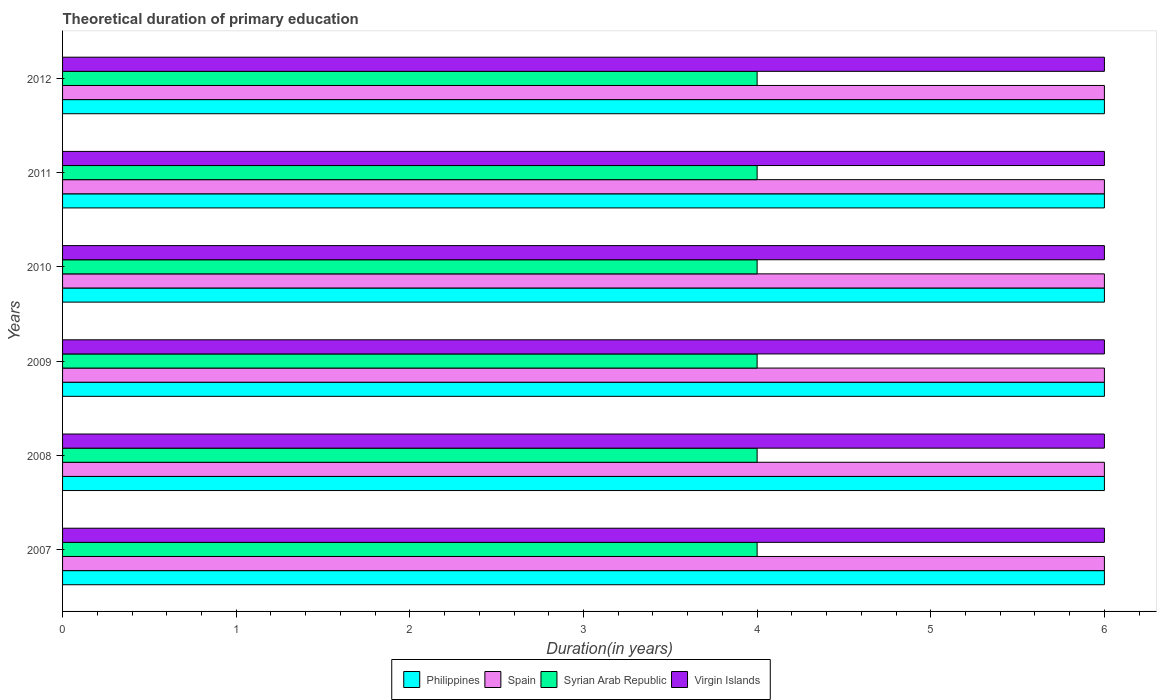How many different coloured bars are there?
Ensure brevity in your answer.  4. How many groups of bars are there?
Provide a short and direct response. 6. Are the number of bars on each tick of the Y-axis equal?
Offer a very short reply. Yes. What is the label of the 2nd group of bars from the top?
Offer a terse response. 2011. What is the total theoretical duration of primary education in Virgin Islands in 2010?
Give a very brief answer. 6. Across all years, what is the minimum total theoretical duration of primary education in Philippines?
Make the answer very short. 6. In which year was the total theoretical duration of primary education in Virgin Islands maximum?
Your answer should be compact. 2007. In which year was the total theoretical duration of primary education in Virgin Islands minimum?
Your answer should be very brief. 2007. What is the total total theoretical duration of primary education in Philippines in the graph?
Give a very brief answer. 36. What is the difference between the total theoretical duration of primary education in Syrian Arab Republic in 2009 and that in 2010?
Make the answer very short. 0. What is the difference between the total theoretical duration of primary education in Spain in 2007 and the total theoretical duration of primary education in Virgin Islands in 2012?
Your response must be concise. 0. In how many years, is the total theoretical duration of primary education in Spain greater than 4 years?
Your answer should be compact. 6. What is the ratio of the total theoretical duration of primary education in Spain in 2009 to that in 2011?
Provide a succinct answer. 1. Is the total theoretical duration of primary education in Philippines in 2011 less than that in 2012?
Keep it short and to the point. No. Is the difference between the total theoretical duration of primary education in Philippines in 2010 and 2011 greater than the difference between the total theoretical duration of primary education in Spain in 2010 and 2011?
Provide a short and direct response. No. What is the difference between the highest and the lowest total theoretical duration of primary education in Spain?
Make the answer very short. 0. In how many years, is the total theoretical duration of primary education in Virgin Islands greater than the average total theoretical duration of primary education in Virgin Islands taken over all years?
Make the answer very short. 0. Is the sum of the total theoretical duration of primary education in Syrian Arab Republic in 2007 and 2010 greater than the maximum total theoretical duration of primary education in Virgin Islands across all years?
Give a very brief answer. Yes. What does the 3rd bar from the top in 2012 represents?
Make the answer very short. Spain. What does the 4th bar from the bottom in 2012 represents?
Your response must be concise. Virgin Islands. Are all the bars in the graph horizontal?
Give a very brief answer. Yes. Are the values on the major ticks of X-axis written in scientific E-notation?
Keep it short and to the point. No. Does the graph contain grids?
Ensure brevity in your answer.  No. Where does the legend appear in the graph?
Ensure brevity in your answer.  Bottom center. How are the legend labels stacked?
Your response must be concise. Horizontal. What is the title of the graph?
Offer a very short reply. Theoretical duration of primary education. Does "Vanuatu" appear as one of the legend labels in the graph?
Make the answer very short. No. What is the label or title of the X-axis?
Your response must be concise. Duration(in years). What is the Duration(in years) of Philippines in 2007?
Provide a short and direct response. 6. What is the Duration(in years) in Spain in 2007?
Provide a short and direct response. 6. What is the Duration(in years) in Virgin Islands in 2007?
Keep it short and to the point. 6. What is the Duration(in years) of Spain in 2008?
Make the answer very short. 6. What is the Duration(in years) in Spain in 2009?
Your answer should be very brief. 6. What is the Duration(in years) of Syrian Arab Republic in 2009?
Your answer should be very brief. 4. What is the Duration(in years) in Virgin Islands in 2009?
Offer a terse response. 6. What is the Duration(in years) of Spain in 2010?
Offer a very short reply. 6. What is the Duration(in years) in Syrian Arab Republic in 2010?
Your response must be concise. 4. What is the Duration(in years) of Virgin Islands in 2010?
Provide a succinct answer. 6. Across all years, what is the maximum Duration(in years) in Philippines?
Your answer should be compact. 6. Across all years, what is the maximum Duration(in years) of Spain?
Your answer should be compact. 6. Across all years, what is the maximum Duration(in years) in Syrian Arab Republic?
Make the answer very short. 4. Across all years, what is the maximum Duration(in years) of Virgin Islands?
Give a very brief answer. 6. What is the total Duration(in years) in Philippines in the graph?
Your answer should be compact. 36. What is the total Duration(in years) of Spain in the graph?
Your answer should be compact. 36. What is the total Duration(in years) of Syrian Arab Republic in the graph?
Keep it short and to the point. 24. What is the total Duration(in years) in Virgin Islands in the graph?
Provide a short and direct response. 36. What is the difference between the Duration(in years) in Philippines in 2007 and that in 2008?
Give a very brief answer. 0. What is the difference between the Duration(in years) of Spain in 2007 and that in 2009?
Your answer should be compact. 0. What is the difference between the Duration(in years) in Virgin Islands in 2007 and that in 2009?
Your response must be concise. 0. What is the difference between the Duration(in years) in Philippines in 2007 and that in 2010?
Keep it short and to the point. 0. What is the difference between the Duration(in years) in Syrian Arab Republic in 2007 and that in 2011?
Offer a very short reply. 0. What is the difference between the Duration(in years) in Virgin Islands in 2007 and that in 2011?
Your answer should be compact. 0. What is the difference between the Duration(in years) of Philippines in 2007 and that in 2012?
Offer a terse response. 0. What is the difference between the Duration(in years) of Spain in 2007 and that in 2012?
Your answer should be compact. 0. What is the difference between the Duration(in years) of Philippines in 2008 and that in 2009?
Ensure brevity in your answer.  0. What is the difference between the Duration(in years) in Syrian Arab Republic in 2008 and that in 2009?
Provide a short and direct response. 0. What is the difference between the Duration(in years) in Virgin Islands in 2008 and that in 2009?
Ensure brevity in your answer.  0. What is the difference between the Duration(in years) in Spain in 2008 and that in 2010?
Keep it short and to the point. 0. What is the difference between the Duration(in years) in Syrian Arab Republic in 2008 and that in 2010?
Your answer should be very brief. 0. What is the difference between the Duration(in years) of Spain in 2008 and that in 2011?
Offer a very short reply. 0. What is the difference between the Duration(in years) of Virgin Islands in 2008 and that in 2011?
Offer a very short reply. 0. What is the difference between the Duration(in years) of Spain in 2008 and that in 2012?
Provide a short and direct response. 0. What is the difference between the Duration(in years) of Syrian Arab Republic in 2008 and that in 2012?
Give a very brief answer. 0. What is the difference between the Duration(in years) of Virgin Islands in 2008 and that in 2012?
Provide a short and direct response. 0. What is the difference between the Duration(in years) of Philippines in 2009 and that in 2010?
Your answer should be very brief. 0. What is the difference between the Duration(in years) of Syrian Arab Republic in 2009 and that in 2010?
Your answer should be compact. 0. What is the difference between the Duration(in years) in Virgin Islands in 2009 and that in 2010?
Provide a succinct answer. 0. What is the difference between the Duration(in years) in Syrian Arab Republic in 2009 and that in 2011?
Your answer should be compact. 0. What is the difference between the Duration(in years) of Syrian Arab Republic in 2009 and that in 2012?
Offer a terse response. 0. What is the difference between the Duration(in years) in Virgin Islands in 2009 and that in 2012?
Provide a short and direct response. 0. What is the difference between the Duration(in years) of Spain in 2010 and that in 2011?
Offer a terse response. 0. What is the difference between the Duration(in years) in Virgin Islands in 2010 and that in 2011?
Ensure brevity in your answer.  0. What is the difference between the Duration(in years) in Syrian Arab Republic in 2010 and that in 2012?
Ensure brevity in your answer.  0. What is the difference between the Duration(in years) of Virgin Islands in 2010 and that in 2012?
Your response must be concise. 0. What is the difference between the Duration(in years) of Philippines in 2011 and that in 2012?
Your response must be concise. 0. What is the difference between the Duration(in years) in Syrian Arab Republic in 2011 and that in 2012?
Offer a terse response. 0. What is the difference between the Duration(in years) in Virgin Islands in 2011 and that in 2012?
Make the answer very short. 0. What is the difference between the Duration(in years) of Philippines in 2007 and the Duration(in years) of Virgin Islands in 2008?
Provide a short and direct response. 0. What is the difference between the Duration(in years) in Syrian Arab Republic in 2007 and the Duration(in years) in Virgin Islands in 2008?
Provide a short and direct response. -2. What is the difference between the Duration(in years) of Philippines in 2007 and the Duration(in years) of Spain in 2009?
Offer a very short reply. 0. What is the difference between the Duration(in years) in Philippines in 2007 and the Duration(in years) in Syrian Arab Republic in 2009?
Your response must be concise. 2. What is the difference between the Duration(in years) in Philippines in 2007 and the Duration(in years) in Virgin Islands in 2009?
Keep it short and to the point. 0. What is the difference between the Duration(in years) of Spain in 2007 and the Duration(in years) of Syrian Arab Republic in 2009?
Ensure brevity in your answer.  2. What is the difference between the Duration(in years) in Spain in 2007 and the Duration(in years) in Virgin Islands in 2009?
Provide a short and direct response. 0. What is the difference between the Duration(in years) in Syrian Arab Republic in 2007 and the Duration(in years) in Virgin Islands in 2009?
Keep it short and to the point. -2. What is the difference between the Duration(in years) in Philippines in 2007 and the Duration(in years) in Spain in 2010?
Make the answer very short. 0. What is the difference between the Duration(in years) in Philippines in 2007 and the Duration(in years) in Syrian Arab Republic in 2010?
Ensure brevity in your answer.  2. What is the difference between the Duration(in years) of Spain in 2007 and the Duration(in years) of Syrian Arab Republic in 2010?
Give a very brief answer. 2. What is the difference between the Duration(in years) in Philippines in 2007 and the Duration(in years) in Spain in 2011?
Your answer should be very brief. 0. What is the difference between the Duration(in years) in Spain in 2007 and the Duration(in years) in Syrian Arab Republic in 2011?
Your answer should be compact. 2. What is the difference between the Duration(in years) in Syrian Arab Republic in 2007 and the Duration(in years) in Virgin Islands in 2011?
Your response must be concise. -2. What is the difference between the Duration(in years) in Philippines in 2007 and the Duration(in years) in Spain in 2012?
Make the answer very short. 0. What is the difference between the Duration(in years) of Philippines in 2007 and the Duration(in years) of Syrian Arab Republic in 2012?
Offer a terse response. 2. What is the difference between the Duration(in years) in Spain in 2007 and the Duration(in years) in Syrian Arab Republic in 2012?
Ensure brevity in your answer.  2. What is the difference between the Duration(in years) in Spain in 2007 and the Duration(in years) in Virgin Islands in 2012?
Provide a succinct answer. 0. What is the difference between the Duration(in years) of Philippines in 2008 and the Duration(in years) of Syrian Arab Republic in 2009?
Ensure brevity in your answer.  2. What is the difference between the Duration(in years) in Philippines in 2008 and the Duration(in years) in Virgin Islands in 2009?
Your answer should be very brief. 0. What is the difference between the Duration(in years) of Spain in 2008 and the Duration(in years) of Virgin Islands in 2009?
Keep it short and to the point. 0. What is the difference between the Duration(in years) in Syrian Arab Republic in 2008 and the Duration(in years) in Virgin Islands in 2009?
Your answer should be compact. -2. What is the difference between the Duration(in years) of Philippines in 2008 and the Duration(in years) of Syrian Arab Republic in 2010?
Offer a very short reply. 2. What is the difference between the Duration(in years) in Spain in 2008 and the Duration(in years) in Syrian Arab Republic in 2010?
Keep it short and to the point. 2. What is the difference between the Duration(in years) of Syrian Arab Republic in 2008 and the Duration(in years) of Virgin Islands in 2010?
Provide a short and direct response. -2. What is the difference between the Duration(in years) in Philippines in 2008 and the Duration(in years) in Spain in 2011?
Give a very brief answer. 0. What is the difference between the Duration(in years) of Philippines in 2008 and the Duration(in years) of Syrian Arab Republic in 2011?
Your answer should be very brief. 2. What is the difference between the Duration(in years) in Spain in 2008 and the Duration(in years) in Virgin Islands in 2011?
Ensure brevity in your answer.  0. What is the difference between the Duration(in years) in Philippines in 2008 and the Duration(in years) in Syrian Arab Republic in 2012?
Make the answer very short. 2. What is the difference between the Duration(in years) in Spain in 2008 and the Duration(in years) in Syrian Arab Republic in 2012?
Your answer should be compact. 2. What is the difference between the Duration(in years) in Philippines in 2009 and the Duration(in years) in Spain in 2010?
Provide a short and direct response. 0. What is the difference between the Duration(in years) in Philippines in 2009 and the Duration(in years) in Syrian Arab Republic in 2010?
Give a very brief answer. 2. What is the difference between the Duration(in years) in Spain in 2009 and the Duration(in years) in Syrian Arab Republic in 2010?
Offer a terse response. 2. What is the difference between the Duration(in years) of Spain in 2009 and the Duration(in years) of Virgin Islands in 2010?
Provide a short and direct response. 0. What is the difference between the Duration(in years) in Syrian Arab Republic in 2009 and the Duration(in years) in Virgin Islands in 2010?
Offer a very short reply. -2. What is the difference between the Duration(in years) in Philippines in 2009 and the Duration(in years) in Spain in 2011?
Your response must be concise. 0. What is the difference between the Duration(in years) in Philippines in 2009 and the Duration(in years) in Virgin Islands in 2011?
Make the answer very short. 0. What is the difference between the Duration(in years) of Philippines in 2009 and the Duration(in years) of Virgin Islands in 2012?
Ensure brevity in your answer.  0. What is the difference between the Duration(in years) in Philippines in 2010 and the Duration(in years) in Syrian Arab Republic in 2011?
Make the answer very short. 2. What is the difference between the Duration(in years) of Spain in 2010 and the Duration(in years) of Syrian Arab Republic in 2011?
Your answer should be very brief. 2. What is the difference between the Duration(in years) in Spain in 2010 and the Duration(in years) in Virgin Islands in 2011?
Provide a succinct answer. 0. What is the difference between the Duration(in years) in Philippines in 2010 and the Duration(in years) in Spain in 2012?
Give a very brief answer. 0. What is the difference between the Duration(in years) of Philippines in 2010 and the Duration(in years) of Syrian Arab Republic in 2012?
Provide a succinct answer. 2. What is the difference between the Duration(in years) in Philippines in 2011 and the Duration(in years) in Spain in 2012?
Your answer should be compact. 0. What is the average Duration(in years) in Philippines per year?
Your answer should be compact. 6. In the year 2007, what is the difference between the Duration(in years) of Spain and Duration(in years) of Syrian Arab Republic?
Your response must be concise. 2. In the year 2008, what is the difference between the Duration(in years) in Spain and Duration(in years) in Virgin Islands?
Provide a succinct answer. 0. In the year 2008, what is the difference between the Duration(in years) in Syrian Arab Republic and Duration(in years) in Virgin Islands?
Offer a very short reply. -2. In the year 2009, what is the difference between the Duration(in years) of Philippines and Duration(in years) of Spain?
Provide a short and direct response. 0. In the year 2009, what is the difference between the Duration(in years) of Philippines and Duration(in years) of Syrian Arab Republic?
Provide a short and direct response. 2. In the year 2009, what is the difference between the Duration(in years) of Philippines and Duration(in years) of Virgin Islands?
Your answer should be very brief. 0. In the year 2009, what is the difference between the Duration(in years) of Spain and Duration(in years) of Syrian Arab Republic?
Provide a short and direct response. 2. In the year 2009, what is the difference between the Duration(in years) in Spain and Duration(in years) in Virgin Islands?
Your answer should be very brief. 0. In the year 2010, what is the difference between the Duration(in years) in Philippines and Duration(in years) in Virgin Islands?
Make the answer very short. 0. In the year 2010, what is the difference between the Duration(in years) of Spain and Duration(in years) of Syrian Arab Republic?
Provide a succinct answer. 2. In the year 2010, what is the difference between the Duration(in years) in Syrian Arab Republic and Duration(in years) in Virgin Islands?
Provide a succinct answer. -2. In the year 2011, what is the difference between the Duration(in years) of Philippines and Duration(in years) of Spain?
Offer a very short reply. 0. In the year 2011, what is the difference between the Duration(in years) of Philippines and Duration(in years) of Syrian Arab Republic?
Provide a short and direct response. 2. In the year 2011, what is the difference between the Duration(in years) in Philippines and Duration(in years) in Virgin Islands?
Your answer should be compact. 0. In the year 2011, what is the difference between the Duration(in years) in Syrian Arab Republic and Duration(in years) in Virgin Islands?
Provide a succinct answer. -2. In the year 2012, what is the difference between the Duration(in years) in Philippines and Duration(in years) in Syrian Arab Republic?
Your answer should be very brief. 2. In the year 2012, what is the difference between the Duration(in years) in Philippines and Duration(in years) in Virgin Islands?
Keep it short and to the point. 0. In the year 2012, what is the difference between the Duration(in years) in Spain and Duration(in years) in Syrian Arab Republic?
Give a very brief answer. 2. What is the ratio of the Duration(in years) in Philippines in 2007 to that in 2008?
Offer a terse response. 1. What is the ratio of the Duration(in years) in Syrian Arab Republic in 2007 to that in 2008?
Your response must be concise. 1. What is the ratio of the Duration(in years) in Virgin Islands in 2007 to that in 2008?
Give a very brief answer. 1. What is the ratio of the Duration(in years) of Philippines in 2007 to that in 2009?
Your response must be concise. 1. What is the ratio of the Duration(in years) in Syrian Arab Republic in 2007 to that in 2009?
Your answer should be compact. 1. What is the ratio of the Duration(in years) in Virgin Islands in 2007 to that in 2009?
Keep it short and to the point. 1. What is the ratio of the Duration(in years) of Philippines in 2007 to that in 2010?
Your response must be concise. 1. What is the ratio of the Duration(in years) in Syrian Arab Republic in 2007 to that in 2010?
Provide a short and direct response. 1. What is the ratio of the Duration(in years) of Virgin Islands in 2007 to that in 2010?
Your answer should be compact. 1. What is the ratio of the Duration(in years) of Philippines in 2007 to that in 2011?
Your answer should be very brief. 1. What is the ratio of the Duration(in years) in Spain in 2007 to that in 2011?
Your response must be concise. 1. What is the ratio of the Duration(in years) in Syrian Arab Republic in 2007 to that in 2011?
Give a very brief answer. 1. What is the ratio of the Duration(in years) of Philippines in 2007 to that in 2012?
Ensure brevity in your answer.  1. What is the ratio of the Duration(in years) in Spain in 2007 to that in 2012?
Offer a terse response. 1. What is the ratio of the Duration(in years) of Virgin Islands in 2007 to that in 2012?
Your answer should be very brief. 1. What is the ratio of the Duration(in years) of Spain in 2008 to that in 2009?
Your answer should be very brief. 1. What is the ratio of the Duration(in years) of Philippines in 2008 to that in 2010?
Keep it short and to the point. 1. What is the ratio of the Duration(in years) of Spain in 2008 to that in 2010?
Offer a terse response. 1. What is the ratio of the Duration(in years) of Virgin Islands in 2008 to that in 2010?
Your answer should be very brief. 1. What is the ratio of the Duration(in years) in Spain in 2008 to that in 2011?
Provide a succinct answer. 1. What is the ratio of the Duration(in years) in Syrian Arab Republic in 2008 to that in 2011?
Offer a very short reply. 1. What is the ratio of the Duration(in years) of Virgin Islands in 2008 to that in 2011?
Offer a terse response. 1. What is the ratio of the Duration(in years) of Philippines in 2009 to that in 2010?
Your answer should be very brief. 1. What is the ratio of the Duration(in years) in Spain in 2009 to that in 2010?
Provide a short and direct response. 1. What is the ratio of the Duration(in years) of Syrian Arab Republic in 2009 to that in 2010?
Provide a short and direct response. 1. What is the ratio of the Duration(in years) of Virgin Islands in 2009 to that in 2010?
Your answer should be very brief. 1. What is the ratio of the Duration(in years) of Syrian Arab Republic in 2009 to that in 2011?
Offer a terse response. 1. What is the ratio of the Duration(in years) in Philippines in 2009 to that in 2012?
Provide a short and direct response. 1. What is the ratio of the Duration(in years) of Spain in 2009 to that in 2012?
Ensure brevity in your answer.  1. What is the ratio of the Duration(in years) in Philippines in 2010 to that in 2011?
Your response must be concise. 1. What is the ratio of the Duration(in years) of Spain in 2010 to that in 2011?
Provide a succinct answer. 1. What is the ratio of the Duration(in years) of Syrian Arab Republic in 2010 to that in 2011?
Your answer should be very brief. 1. What is the ratio of the Duration(in years) of Virgin Islands in 2010 to that in 2011?
Your response must be concise. 1. What is the ratio of the Duration(in years) of Spain in 2010 to that in 2012?
Your answer should be compact. 1. What is the difference between the highest and the second highest Duration(in years) in Spain?
Offer a very short reply. 0. What is the difference between the highest and the lowest Duration(in years) of Philippines?
Give a very brief answer. 0. What is the difference between the highest and the lowest Duration(in years) in Spain?
Offer a very short reply. 0. What is the difference between the highest and the lowest Duration(in years) in Syrian Arab Republic?
Give a very brief answer. 0. 